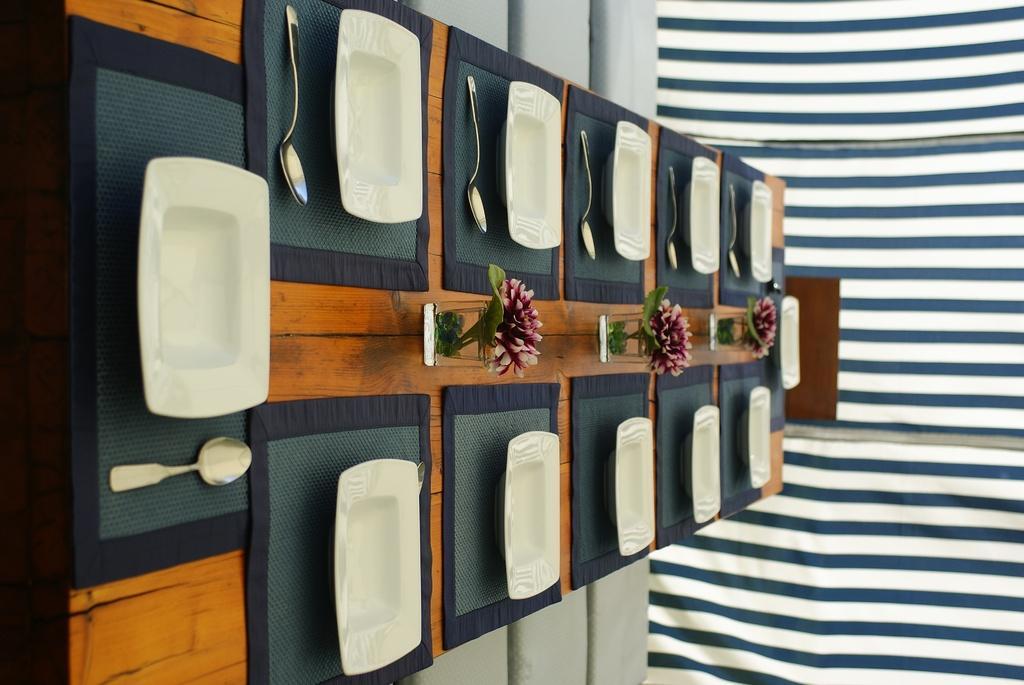Could you give a brief overview of what you see in this image? In this image, we can see a dining table and there are plates, spoons, glasses are placed on the table and in the background, we can see curtains. 